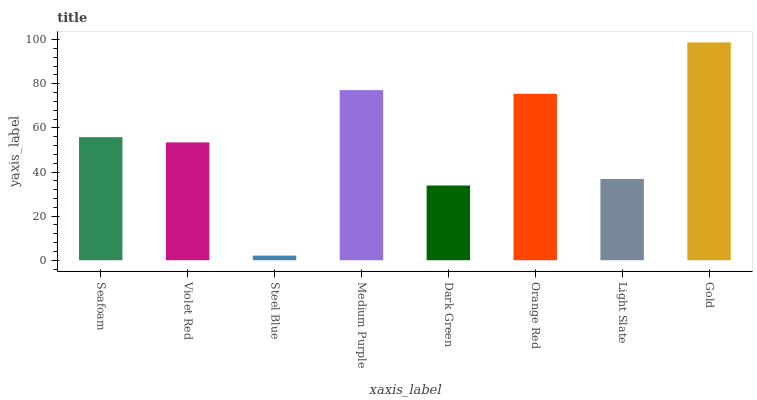Is Steel Blue the minimum?
Answer yes or no. Yes. Is Gold the maximum?
Answer yes or no. Yes. Is Violet Red the minimum?
Answer yes or no. No. Is Violet Red the maximum?
Answer yes or no. No. Is Seafoam greater than Violet Red?
Answer yes or no. Yes. Is Violet Red less than Seafoam?
Answer yes or no. Yes. Is Violet Red greater than Seafoam?
Answer yes or no. No. Is Seafoam less than Violet Red?
Answer yes or no. No. Is Seafoam the high median?
Answer yes or no. Yes. Is Violet Red the low median?
Answer yes or no. Yes. Is Orange Red the high median?
Answer yes or no. No. Is Dark Green the low median?
Answer yes or no. No. 